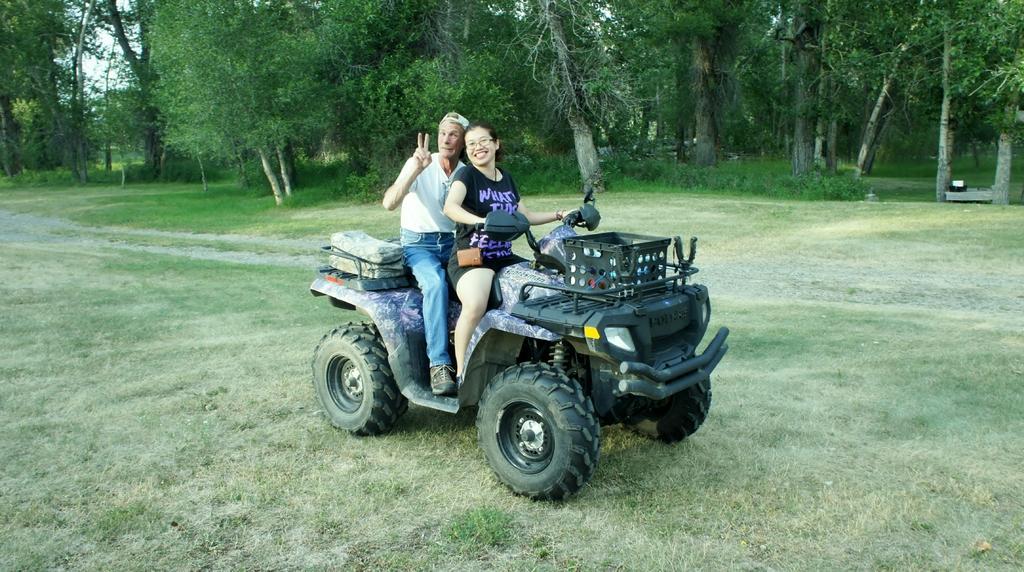Can you describe this image briefly? This image consists of two persons. In the front, the woman sitting on a vehicle is wearing a black T-shirt. Beside her, there is a man sitting is wearing a white T-shirt and a blue jeans. They are both are sitting on a vehicle which is in black color. At the bottom, there is green grass on the ground. In the background, there are many trees. 